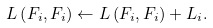<formula> <loc_0><loc_0><loc_500><loc_500>L \left ( F _ { i } , F _ { i } \right ) \leftarrow L \left ( F _ { i } , F _ { i } \right ) + L _ { i } .</formula> 